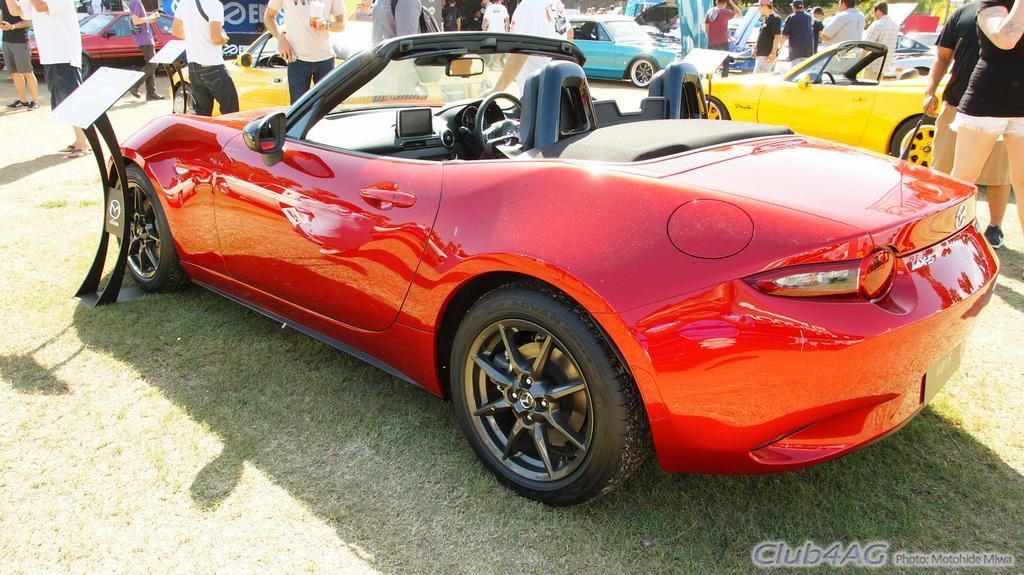How would you summarize this image in a sentence or two? In this image it looks like it is a car exhibition. In the middle there is a red colour car on the ground. Beside it there is a specification board. In the background there are few people standing on the ground and there are cars around them. 